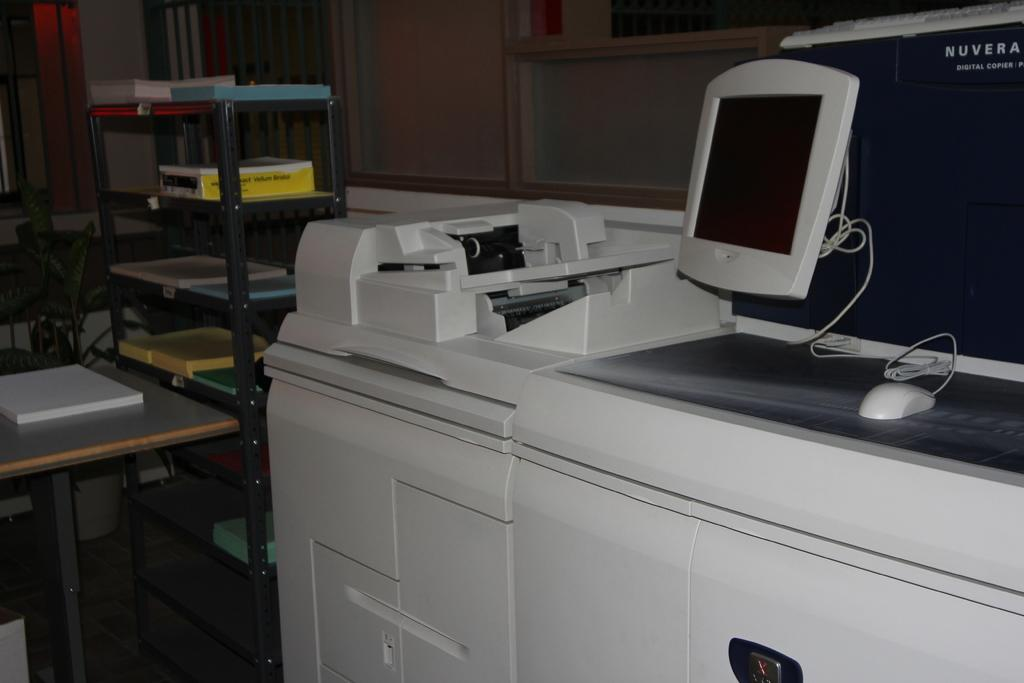<image>
Provide a brief description of the given image. A Nuvera copy machine has a monitor and a computer mouse on it. 